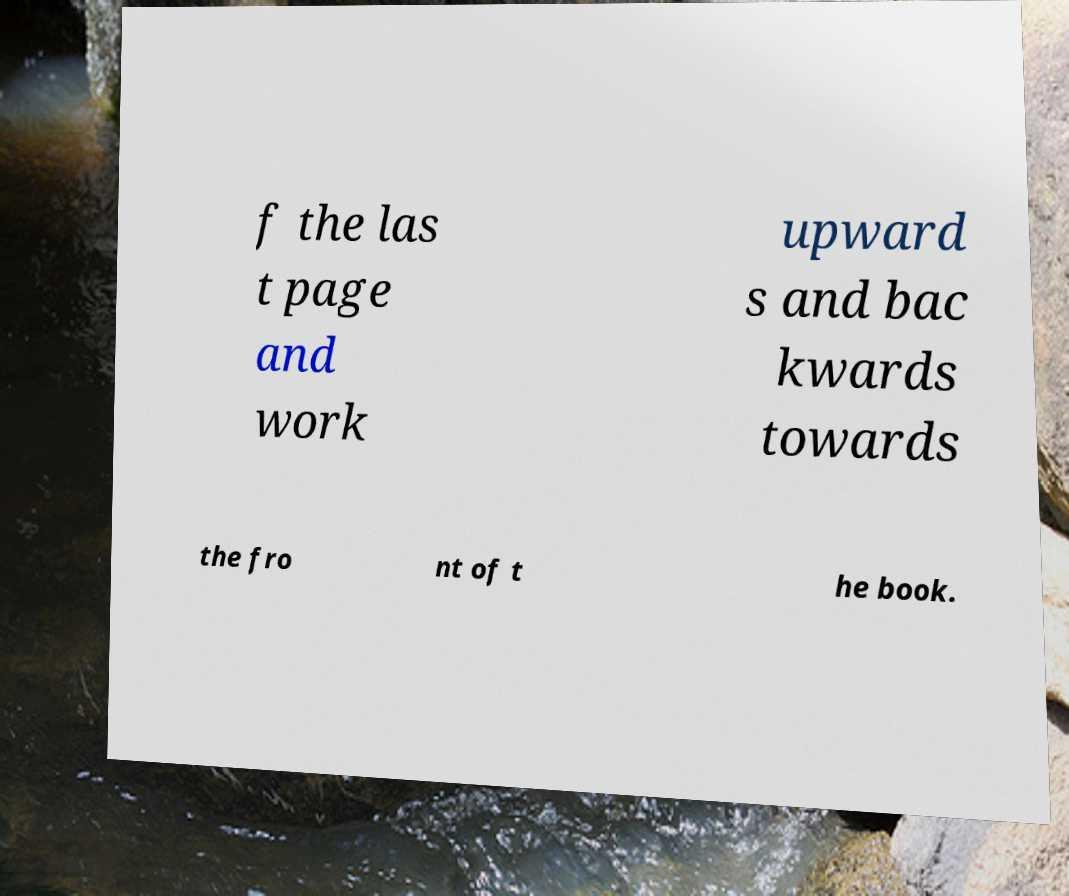What messages or text are displayed in this image? I need them in a readable, typed format. f the las t page and work upward s and bac kwards towards the fro nt of t he book. 